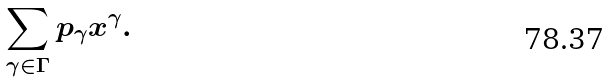Convert formula to latex. <formula><loc_0><loc_0><loc_500><loc_500>\sum _ { \gamma \in \Gamma } p _ { \gamma } x ^ { \gamma } .</formula> 